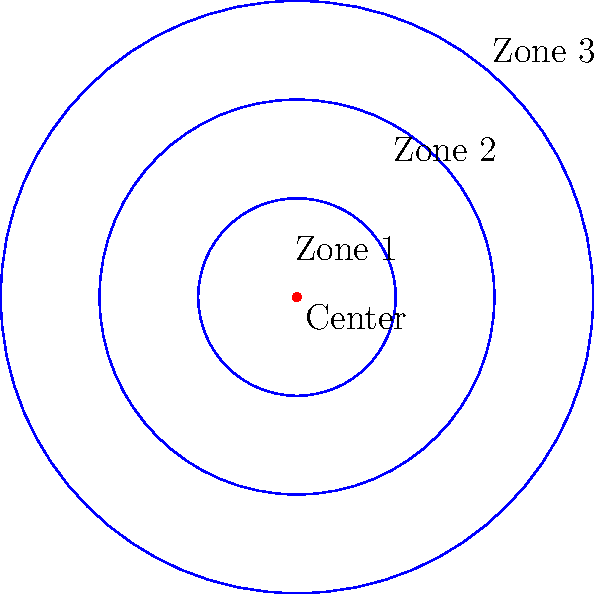A wildlife researcher is studying the population density of a rare species of bird in a circular area. The study area is divided into three concentric zones around a central point, each with a radius of 1 km, 2 km, and 3 km respectively. The number of birds observed in each zone are: 20 in Zone 1, 60 in Zone 2, and 120 in Zone 3. Calculate the overall population density (birds per square kilometer) for the entire study area. To solve this problem, we'll follow these steps:

1) Calculate the area of each zone:
   Zone 1: $A_1 = \pi r_1^2 = \pi (1)^2 = \pi$ km²
   Zone 2: $A_2 = \pi (r_2^2 - r_1^2) = \pi (2^2 - 1^2) = 3\pi$ km²
   Zone 3: $A_3 = \pi (r_3^2 - r_2^2) = \pi (3^2 - 2^2) = 5\pi$ km²

2) Calculate the total area:
   $A_{total} = A_1 + A_2 + A_3 = \pi + 3\pi + 5\pi = 9\pi$ km²

3) Sum up the total number of birds:
   Total birds = 20 + 60 + 120 = 200

4) Calculate the overall population density:
   Density = Total birds / Total area
   $$ \text{Density} = \frac{200}{9\pi} \approx 7.074 \text{ birds/km²} $$
Answer: $\frac{200}{9\pi} \approx 7.074 \text{ birds/km²}$ 